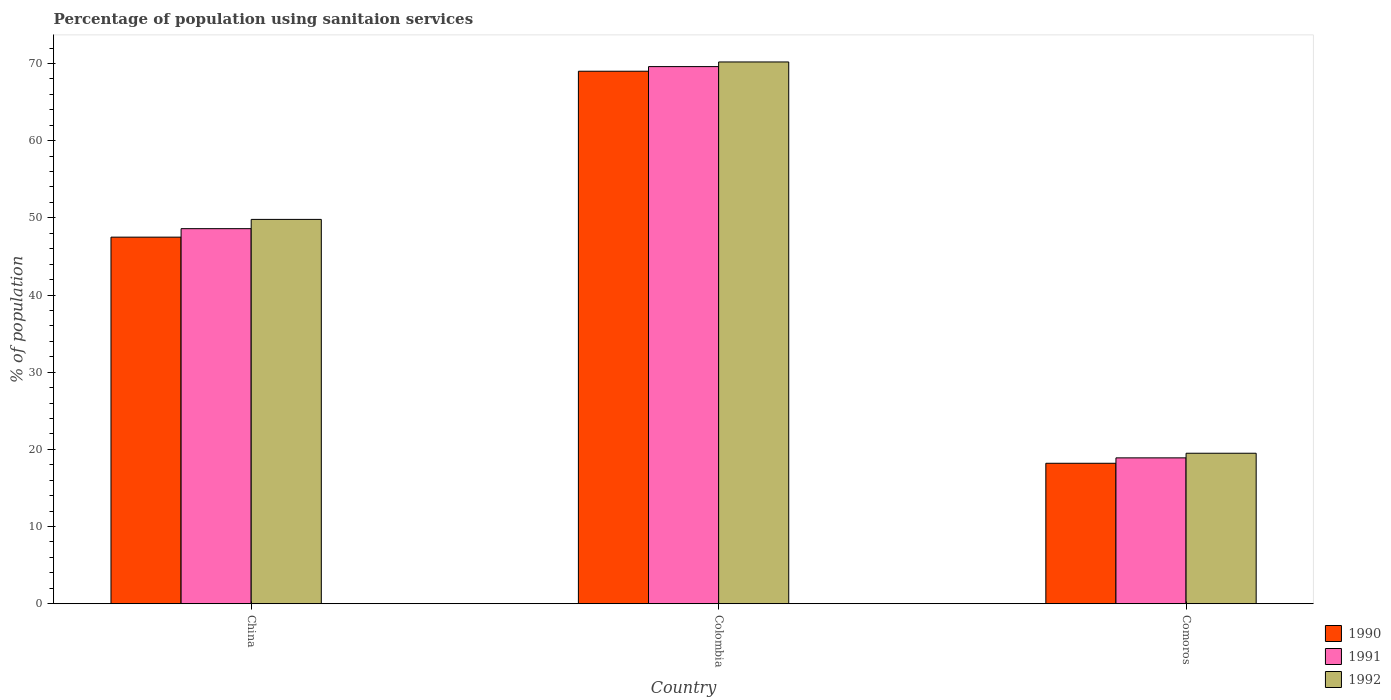How many different coloured bars are there?
Provide a succinct answer. 3. How many groups of bars are there?
Provide a succinct answer. 3. Are the number of bars per tick equal to the number of legend labels?
Provide a succinct answer. Yes. Are the number of bars on each tick of the X-axis equal?
Provide a short and direct response. Yes. How many bars are there on the 1st tick from the left?
Your answer should be very brief. 3. In how many cases, is the number of bars for a given country not equal to the number of legend labels?
Your answer should be compact. 0. What is the percentage of population using sanitaion services in 1991 in Colombia?
Give a very brief answer. 69.6. Across all countries, what is the maximum percentage of population using sanitaion services in 1991?
Your answer should be very brief. 69.6. In which country was the percentage of population using sanitaion services in 1991 minimum?
Offer a very short reply. Comoros. What is the total percentage of population using sanitaion services in 1992 in the graph?
Your answer should be compact. 139.5. What is the difference between the percentage of population using sanitaion services in 1992 in Colombia and that in Comoros?
Your answer should be compact. 50.7. What is the difference between the percentage of population using sanitaion services in 1991 in Comoros and the percentage of population using sanitaion services in 1990 in Colombia?
Your answer should be very brief. -50.1. What is the average percentage of population using sanitaion services in 1992 per country?
Provide a succinct answer. 46.5. What is the difference between the percentage of population using sanitaion services of/in 1990 and percentage of population using sanitaion services of/in 1992 in Comoros?
Offer a terse response. -1.3. In how many countries, is the percentage of population using sanitaion services in 1992 greater than 64 %?
Provide a succinct answer. 1. What is the ratio of the percentage of population using sanitaion services in 1991 in Colombia to that in Comoros?
Your response must be concise. 3.68. Is the percentage of population using sanitaion services in 1992 in Colombia less than that in Comoros?
Provide a short and direct response. No. Is the difference between the percentage of population using sanitaion services in 1990 in Colombia and Comoros greater than the difference between the percentage of population using sanitaion services in 1992 in Colombia and Comoros?
Offer a terse response. Yes. What is the difference between the highest and the second highest percentage of population using sanitaion services in 1991?
Give a very brief answer. 29.7. What is the difference between the highest and the lowest percentage of population using sanitaion services in 1990?
Your answer should be compact. 50.8. What does the 3rd bar from the left in China represents?
Offer a terse response. 1992. What does the 3rd bar from the right in Comoros represents?
Keep it short and to the point. 1990. How many bars are there?
Offer a very short reply. 9. How many countries are there in the graph?
Your response must be concise. 3. Are the values on the major ticks of Y-axis written in scientific E-notation?
Your response must be concise. No. Does the graph contain any zero values?
Your answer should be compact. No. Where does the legend appear in the graph?
Your answer should be compact. Bottom right. How many legend labels are there?
Ensure brevity in your answer.  3. What is the title of the graph?
Make the answer very short. Percentage of population using sanitaion services. What is the label or title of the Y-axis?
Ensure brevity in your answer.  % of population. What is the % of population of 1990 in China?
Keep it short and to the point. 47.5. What is the % of population in 1991 in China?
Ensure brevity in your answer.  48.6. What is the % of population of 1992 in China?
Your answer should be very brief. 49.8. What is the % of population in 1990 in Colombia?
Provide a succinct answer. 69. What is the % of population of 1991 in Colombia?
Ensure brevity in your answer.  69.6. What is the % of population in 1992 in Colombia?
Your response must be concise. 70.2. What is the % of population in 1990 in Comoros?
Offer a very short reply. 18.2. What is the % of population in 1992 in Comoros?
Provide a succinct answer. 19.5. Across all countries, what is the maximum % of population of 1990?
Ensure brevity in your answer.  69. Across all countries, what is the maximum % of population of 1991?
Offer a very short reply. 69.6. Across all countries, what is the maximum % of population of 1992?
Make the answer very short. 70.2. Across all countries, what is the minimum % of population in 1990?
Offer a terse response. 18.2. Across all countries, what is the minimum % of population of 1991?
Your response must be concise. 18.9. Across all countries, what is the minimum % of population in 1992?
Ensure brevity in your answer.  19.5. What is the total % of population in 1990 in the graph?
Your answer should be compact. 134.7. What is the total % of population of 1991 in the graph?
Your answer should be compact. 137.1. What is the total % of population in 1992 in the graph?
Ensure brevity in your answer.  139.5. What is the difference between the % of population of 1990 in China and that in Colombia?
Your response must be concise. -21.5. What is the difference between the % of population of 1992 in China and that in Colombia?
Your answer should be very brief. -20.4. What is the difference between the % of population of 1990 in China and that in Comoros?
Your answer should be compact. 29.3. What is the difference between the % of population of 1991 in China and that in Comoros?
Provide a succinct answer. 29.7. What is the difference between the % of population of 1992 in China and that in Comoros?
Provide a short and direct response. 30.3. What is the difference between the % of population in 1990 in Colombia and that in Comoros?
Offer a terse response. 50.8. What is the difference between the % of population in 1991 in Colombia and that in Comoros?
Provide a short and direct response. 50.7. What is the difference between the % of population of 1992 in Colombia and that in Comoros?
Provide a succinct answer. 50.7. What is the difference between the % of population of 1990 in China and the % of population of 1991 in Colombia?
Ensure brevity in your answer.  -22.1. What is the difference between the % of population in 1990 in China and the % of population in 1992 in Colombia?
Your answer should be very brief. -22.7. What is the difference between the % of population in 1991 in China and the % of population in 1992 in Colombia?
Your answer should be compact. -21.6. What is the difference between the % of population of 1990 in China and the % of population of 1991 in Comoros?
Your answer should be compact. 28.6. What is the difference between the % of population of 1991 in China and the % of population of 1992 in Comoros?
Your answer should be very brief. 29.1. What is the difference between the % of population of 1990 in Colombia and the % of population of 1991 in Comoros?
Offer a terse response. 50.1. What is the difference between the % of population in 1990 in Colombia and the % of population in 1992 in Comoros?
Ensure brevity in your answer.  49.5. What is the difference between the % of population of 1991 in Colombia and the % of population of 1992 in Comoros?
Offer a terse response. 50.1. What is the average % of population of 1990 per country?
Provide a succinct answer. 44.9. What is the average % of population of 1991 per country?
Your response must be concise. 45.7. What is the average % of population in 1992 per country?
Give a very brief answer. 46.5. What is the difference between the % of population in 1990 and % of population in 1992 in China?
Provide a short and direct response. -2.3. What is the difference between the % of population of 1991 and % of population of 1992 in Colombia?
Ensure brevity in your answer.  -0.6. What is the difference between the % of population in 1990 and % of population in 1991 in Comoros?
Make the answer very short. -0.7. What is the difference between the % of population of 1990 and % of population of 1992 in Comoros?
Ensure brevity in your answer.  -1.3. What is the ratio of the % of population in 1990 in China to that in Colombia?
Provide a succinct answer. 0.69. What is the ratio of the % of population of 1991 in China to that in Colombia?
Provide a short and direct response. 0.7. What is the ratio of the % of population of 1992 in China to that in Colombia?
Your answer should be very brief. 0.71. What is the ratio of the % of population of 1990 in China to that in Comoros?
Your response must be concise. 2.61. What is the ratio of the % of population in 1991 in China to that in Comoros?
Provide a succinct answer. 2.57. What is the ratio of the % of population of 1992 in China to that in Comoros?
Your answer should be compact. 2.55. What is the ratio of the % of population in 1990 in Colombia to that in Comoros?
Your response must be concise. 3.79. What is the ratio of the % of population in 1991 in Colombia to that in Comoros?
Keep it short and to the point. 3.68. What is the ratio of the % of population of 1992 in Colombia to that in Comoros?
Provide a succinct answer. 3.6. What is the difference between the highest and the second highest % of population of 1991?
Give a very brief answer. 21. What is the difference between the highest and the second highest % of population in 1992?
Your answer should be very brief. 20.4. What is the difference between the highest and the lowest % of population in 1990?
Provide a short and direct response. 50.8. What is the difference between the highest and the lowest % of population in 1991?
Ensure brevity in your answer.  50.7. What is the difference between the highest and the lowest % of population of 1992?
Your answer should be compact. 50.7. 